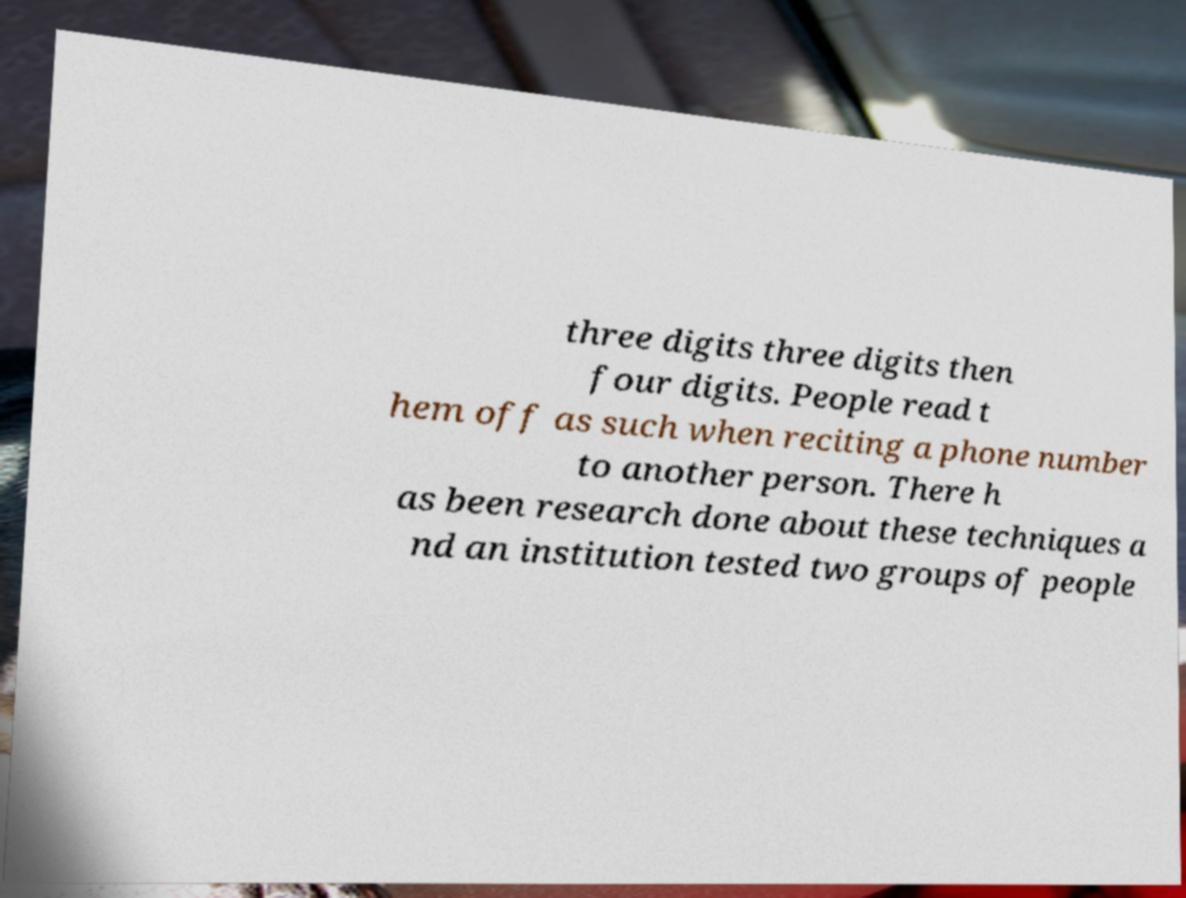For documentation purposes, I need the text within this image transcribed. Could you provide that? three digits three digits then four digits. People read t hem off as such when reciting a phone number to another person. There h as been research done about these techniques a nd an institution tested two groups of people 